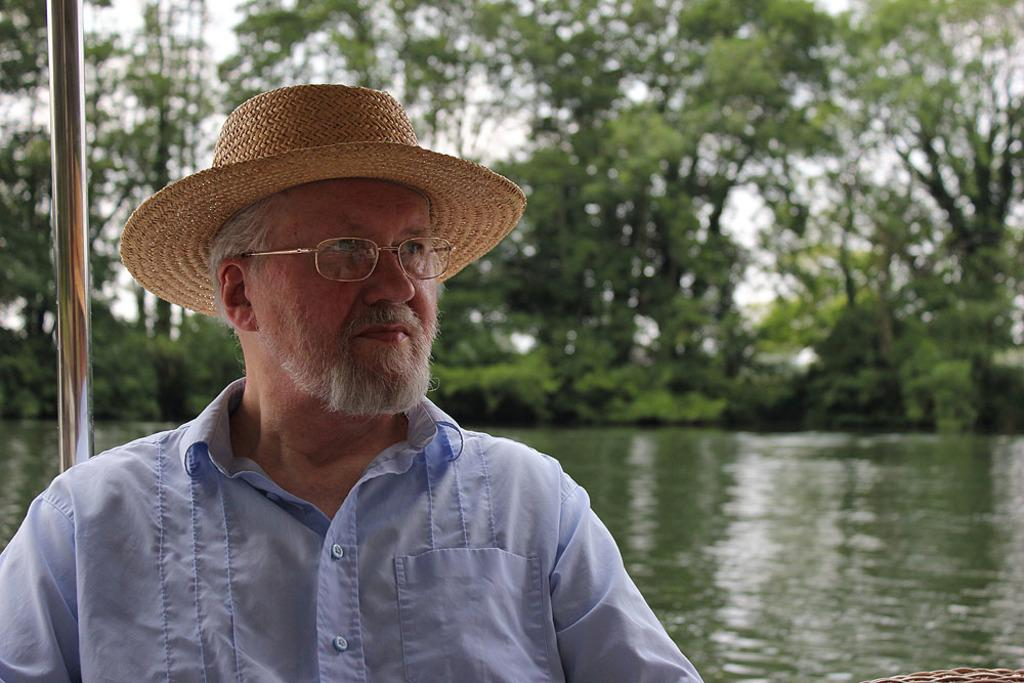What is the man in the image doing? The man is sitting in the image. What accessories is the man wearing? The man is wearing a hat and spectacles. What type of clothing is the man wearing? The man is wearing a shirt. What can be seen in the background of the image? There are trees and plants in the background of the image. What is happening with the water in the image? Water is flowing in the image. Can you describe any other objects in the image? There appears to be a pole in the image. Can you hear the goat whistling in the image? There is no goat or whistling present in the image. How does the man shake hands with the tree in the image? There is no interaction between the man and the tree in the image; the man is simply sitting. 